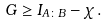Convert formula to latex. <formula><loc_0><loc_0><loc_500><loc_500>G \geq I _ { A \colon B } - \chi \, .</formula> 